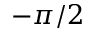<formula> <loc_0><loc_0><loc_500><loc_500>- \pi / 2</formula> 